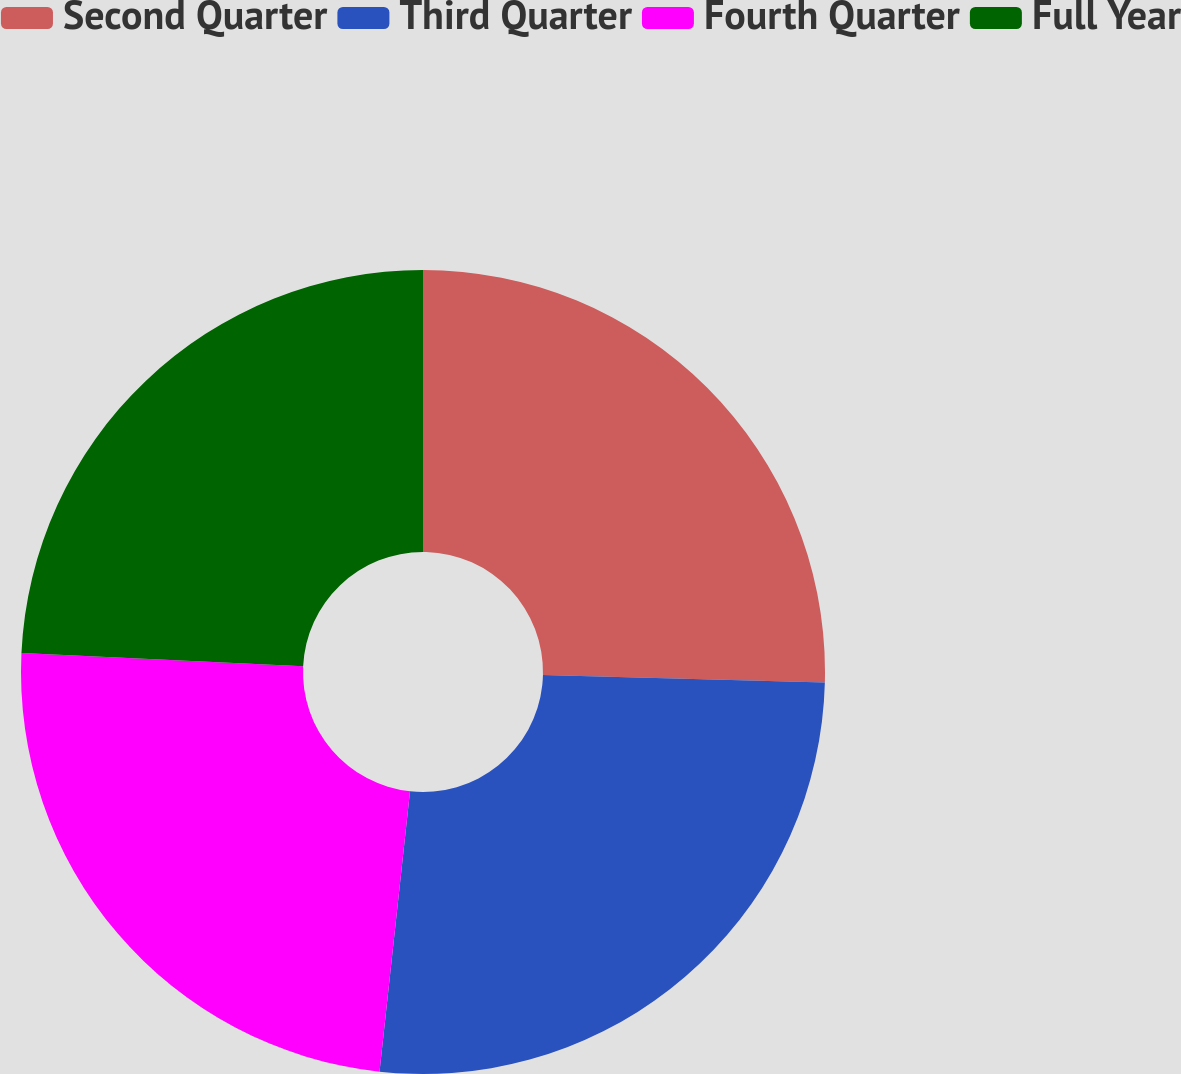Convert chart to OTSL. <chart><loc_0><loc_0><loc_500><loc_500><pie_chart><fcel>Second Quarter<fcel>Third Quarter<fcel>Fourth Quarter<fcel>Full Year<nl><fcel>25.41%<fcel>26.31%<fcel>24.02%<fcel>24.25%<nl></chart> 